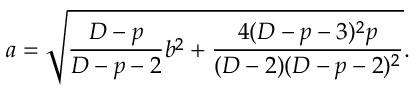<formula> <loc_0><loc_0><loc_500><loc_500>a = \sqrt { { \frac { D - p } { D - p - 2 } } b ^ { 2 } + { \frac { 4 ( D - p - 3 ) ^ { 2 } p } { ( D - 2 ) ( D - p - 2 ) ^ { 2 } } } } .</formula> 